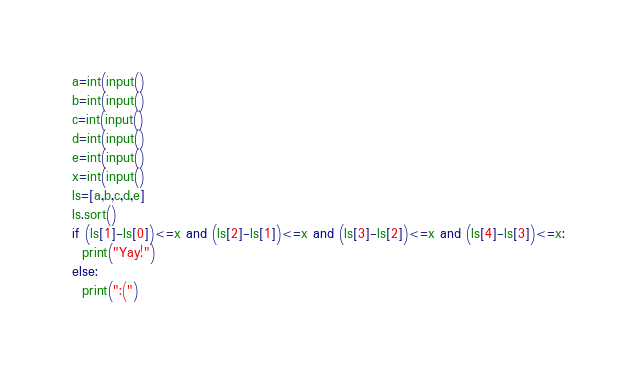Convert code to text. <code><loc_0><loc_0><loc_500><loc_500><_Python_>a=int(input()
b=int(input()
c=int(input()
d=int(input()
e=int(input()
x=int(input()
ls=[a,b,c,d,e]
ls.sort()
if (ls[1]-ls[0])<=x and (ls[2]-ls[1])<=x and (ls[3]-ls[2])<=x and (ls[4]-ls[3])<=x:
  print("Yay!")
else:
  print(":(")</code> 